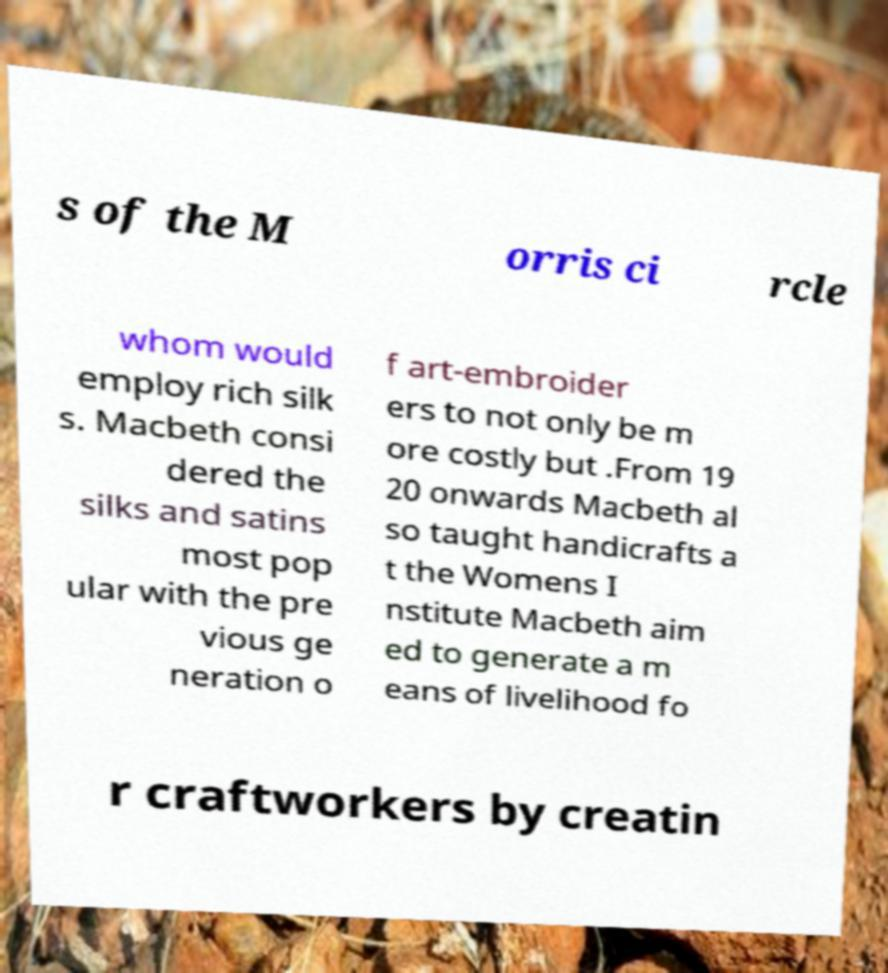Can you read and provide the text displayed in the image?This photo seems to have some interesting text. Can you extract and type it out for me? s of the M orris ci rcle whom would employ rich silk s. Macbeth consi dered the silks and satins most pop ular with the pre vious ge neration o f art-embroider ers to not only be m ore costly but .From 19 20 onwards Macbeth al so taught handicrafts a t the Womens I nstitute Macbeth aim ed to generate a m eans of livelihood fo r craftworkers by creatin 